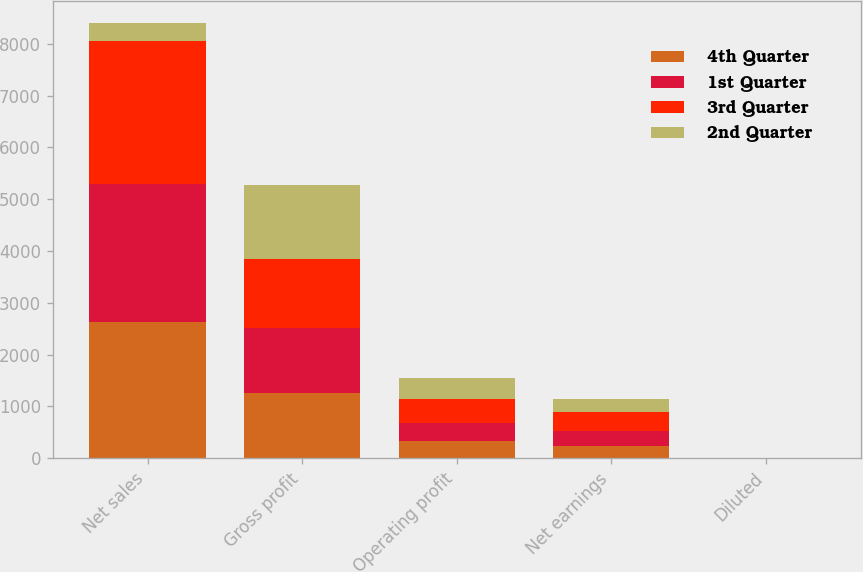<chart> <loc_0><loc_0><loc_500><loc_500><stacked_bar_chart><ecel><fcel>Net sales<fcel>Gross profit<fcel>Operating profit<fcel>Net earnings<fcel>Diluted<nl><fcel>4th Quarter<fcel>2627.7<fcel>1258.6<fcel>340.2<fcel>237.7<fcel>0.36<nl><fcel>1st Quarter<fcel>2673.6<fcel>1262.3<fcel>343.9<fcel>295.7<fcel>0.44<nl><fcel>3rd Quarter<fcel>2750.7<fcel>1320.9<fcel>464.6<fcel>351.4<fcel>0.53<nl><fcel>2nd Quarter<fcel>351.4<fcel>1438.4<fcel>393.8<fcel>266.9<fcel>0.4<nl></chart> 